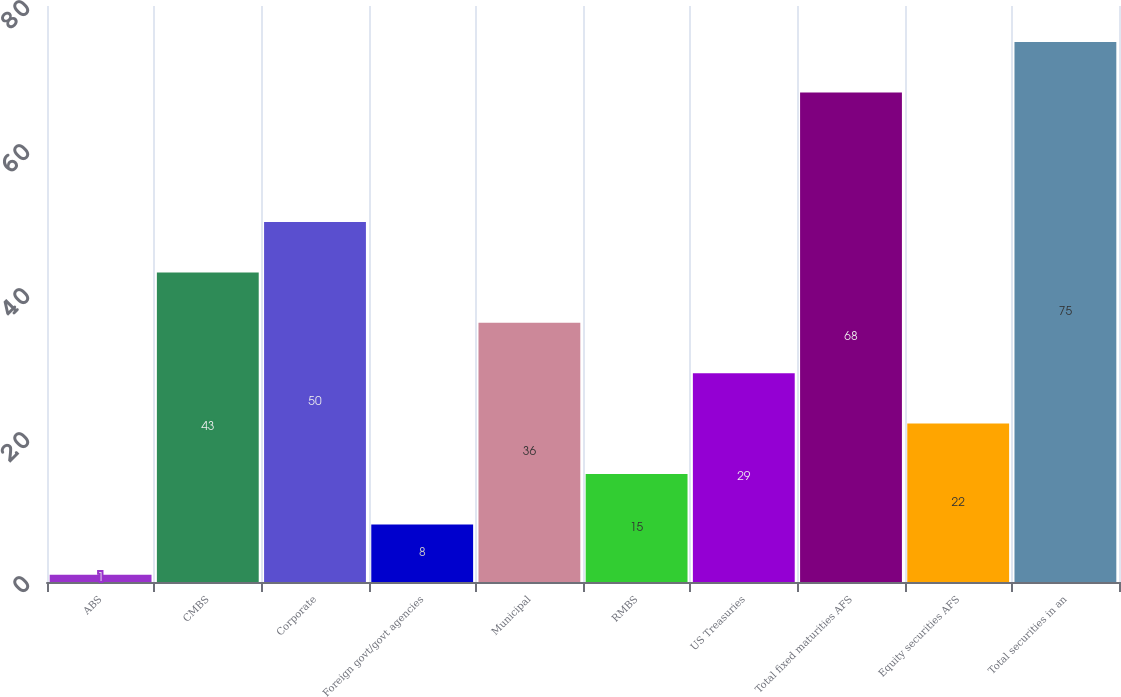<chart> <loc_0><loc_0><loc_500><loc_500><bar_chart><fcel>ABS<fcel>CMBS<fcel>Corporate<fcel>Foreign govt/govt agencies<fcel>Municipal<fcel>RMBS<fcel>US Treasuries<fcel>Total fixed maturities AFS<fcel>Equity securities AFS<fcel>Total securities in an<nl><fcel>1<fcel>43<fcel>50<fcel>8<fcel>36<fcel>15<fcel>29<fcel>68<fcel>22<fcel>75<nl></chart> 